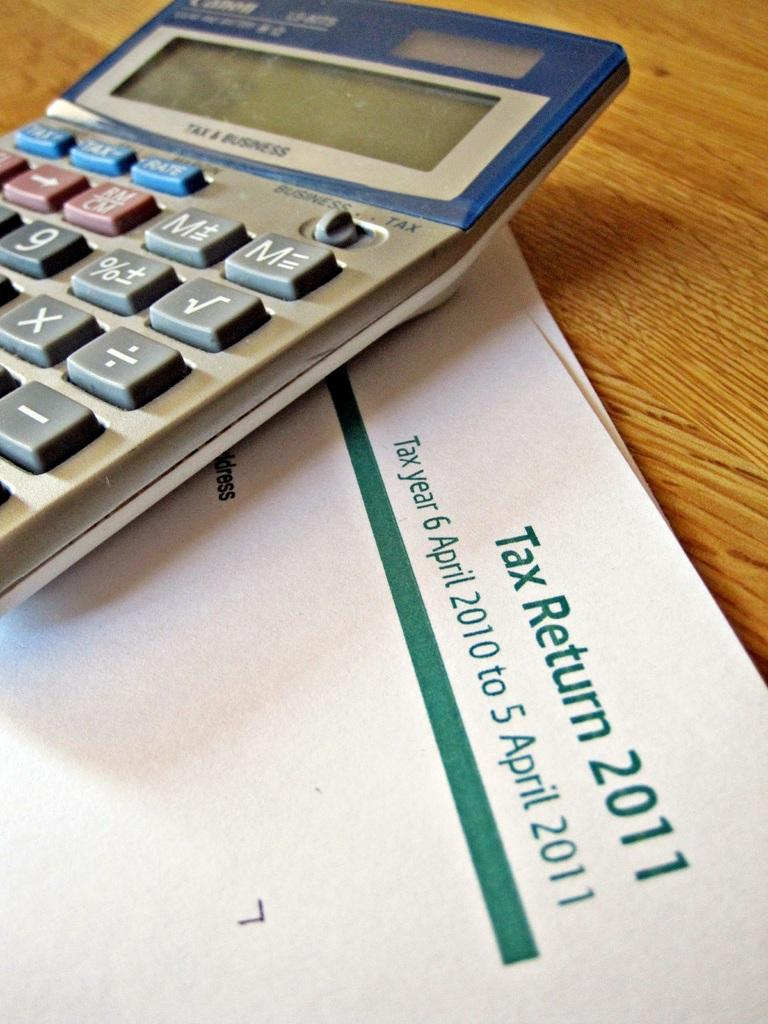<image>
Relay a brief, clear account of the picture shown. a Tax Return 2011 sits under a calculator on a wood table 